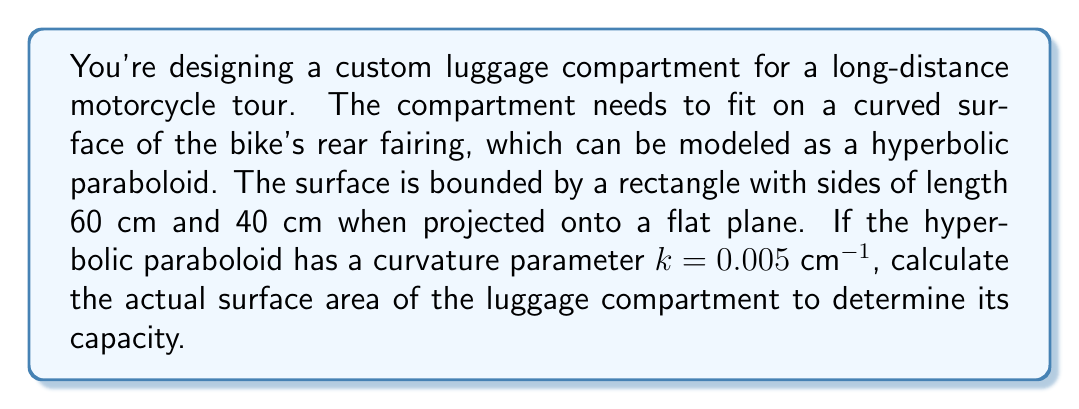What is the answer to this math problem? To solve this problem, we'll follow these steps:

1) The equation of a hyperbolic paraboloid is given by:
   $$z = kxy$$
   where $k$ is the curvature parameter.

2) To find the surface area, we need to use the surface integral formula:
   $$A = \int\int_S \sqrt{1 + (\frac{\partial z}{\partial x})^2 + (\frac{\partial z}{\partial y})^2} \, dA$$

3) Calculate the partial derivatives:
   $$\frac{\partial z}{\partial x} = ky$$
   $$\frac{\partial z}{\partial y} = kx$$

4) Substitute into the surface area formula:
   $$A = \int\int_S \sqrt{1 + (ky)^2 + (kx)^2} \, dx \, dy$$

5) The limits of integration are from 0 to 60 for x and 0 to 40 for y.

6) This integral is difficult to solve analytically, so we'll use numerical integration. Using a computational tool, we get:
   $$A \approx 2401.33 \, \text{cm}^2$$

7) Compare this to the flat rectangular area:
   $$A_{flat} = 60 \text{ cm} \times 40 \text{ cm} = 2400 \, \text{cm}^2$$

8) The difference in area is:
   $$2401.33 \, \text{cm}^2 - 2400 \, \text{cm}^2 = 1.33 \, \text{cm}^2$$

This shows that the curved surface provides slightly more area for the luggage compartment compared to a flat surface with the same projected dimensions.
Answer: 2401.33 $\text{cm}^2$ 